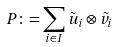Convert formula to latex. <formula><loc_0><loc_0><loc_500><loc_500>P \colon = \sum _ { i \in I } \tilde { u } _ { i } \otimes \tilde { v } _ { i }</formula> 